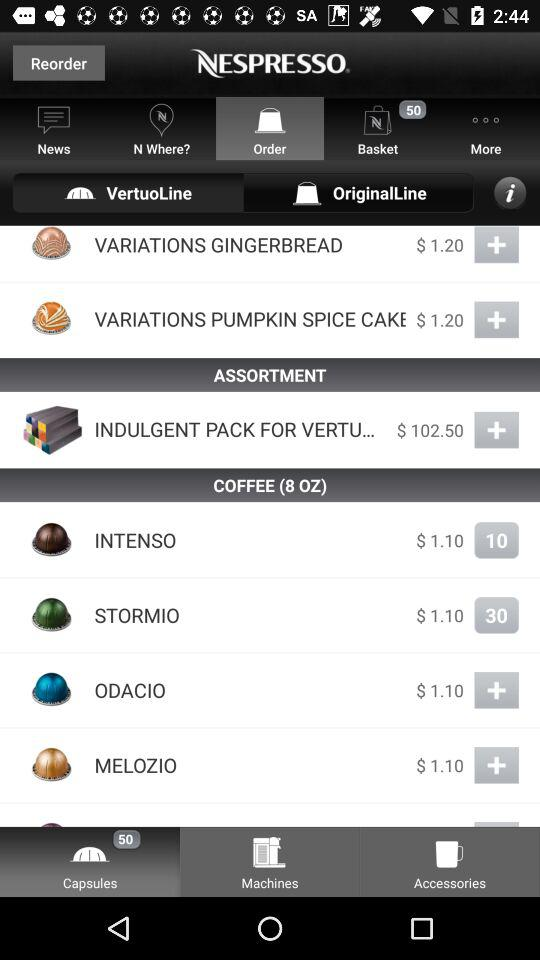What is the price of "VARIATIONS PUMPKIN SPICE CAKE"? The price of "VARIATIONS PUMPKIN SPICE CAKE" is $1.20. 